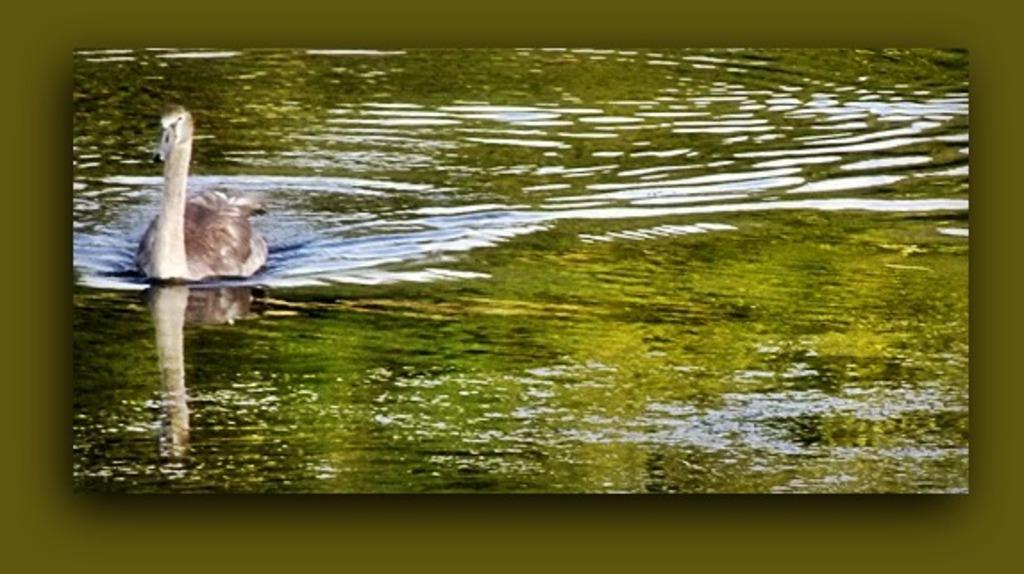What can be observed about the image's appearance? The image is edited. What is present in the water in the image? There is a swan in the water in the image. What type of holiday is being celebrated in the image? There is no indication of a holiday being celebrated in the image, as it only features a swan in the water. What game is being played in the image? There is no game being played in the image; it only features a swan in the water. 